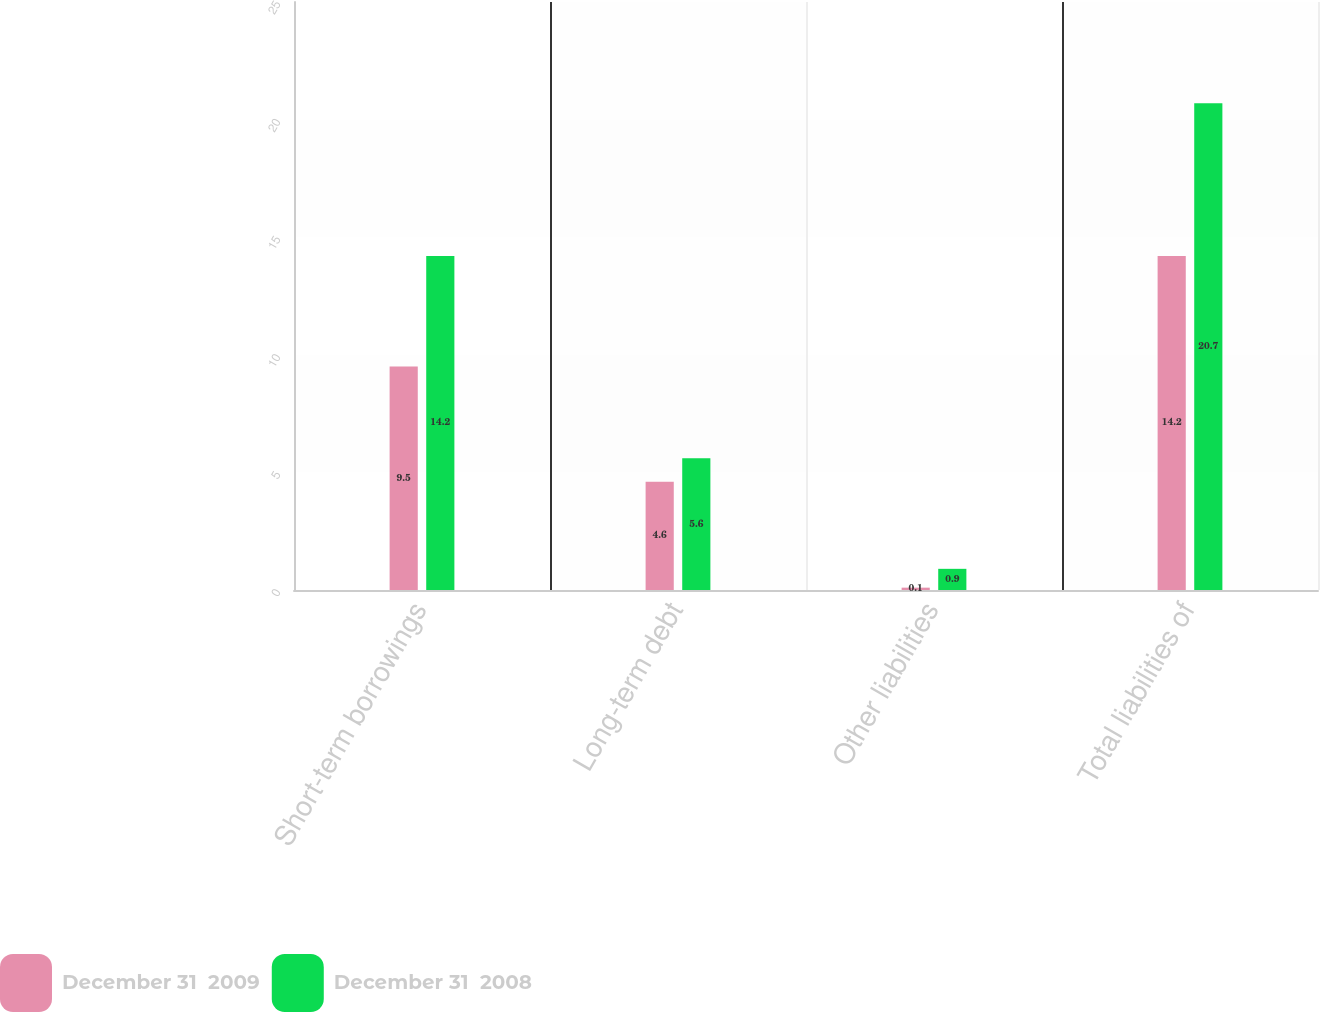<chart> <loc_0><loc_0><loc_500><loc_500><stacked_bar_chart><ecel><fcel>Short-term borrowings<fcel>Long-term debt<fcel>Other liabilities<fcel>Total liabilities of<nl><fcel>December 31  2009<fcel>9.5<fcel>4.6<fcel>0.1<fcel>14.2<nl><fcel>December 31  2008<fcel>14.2<fcel>5.6<fcel>0.9<fcel>20.7<nl></chart> 